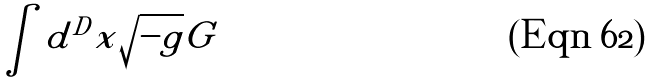Convert formula to latex. <formula><loc_0><loc_0><loc_500><loc_500>\int d ^ { D } x \sqrt { - g } G</formula> 